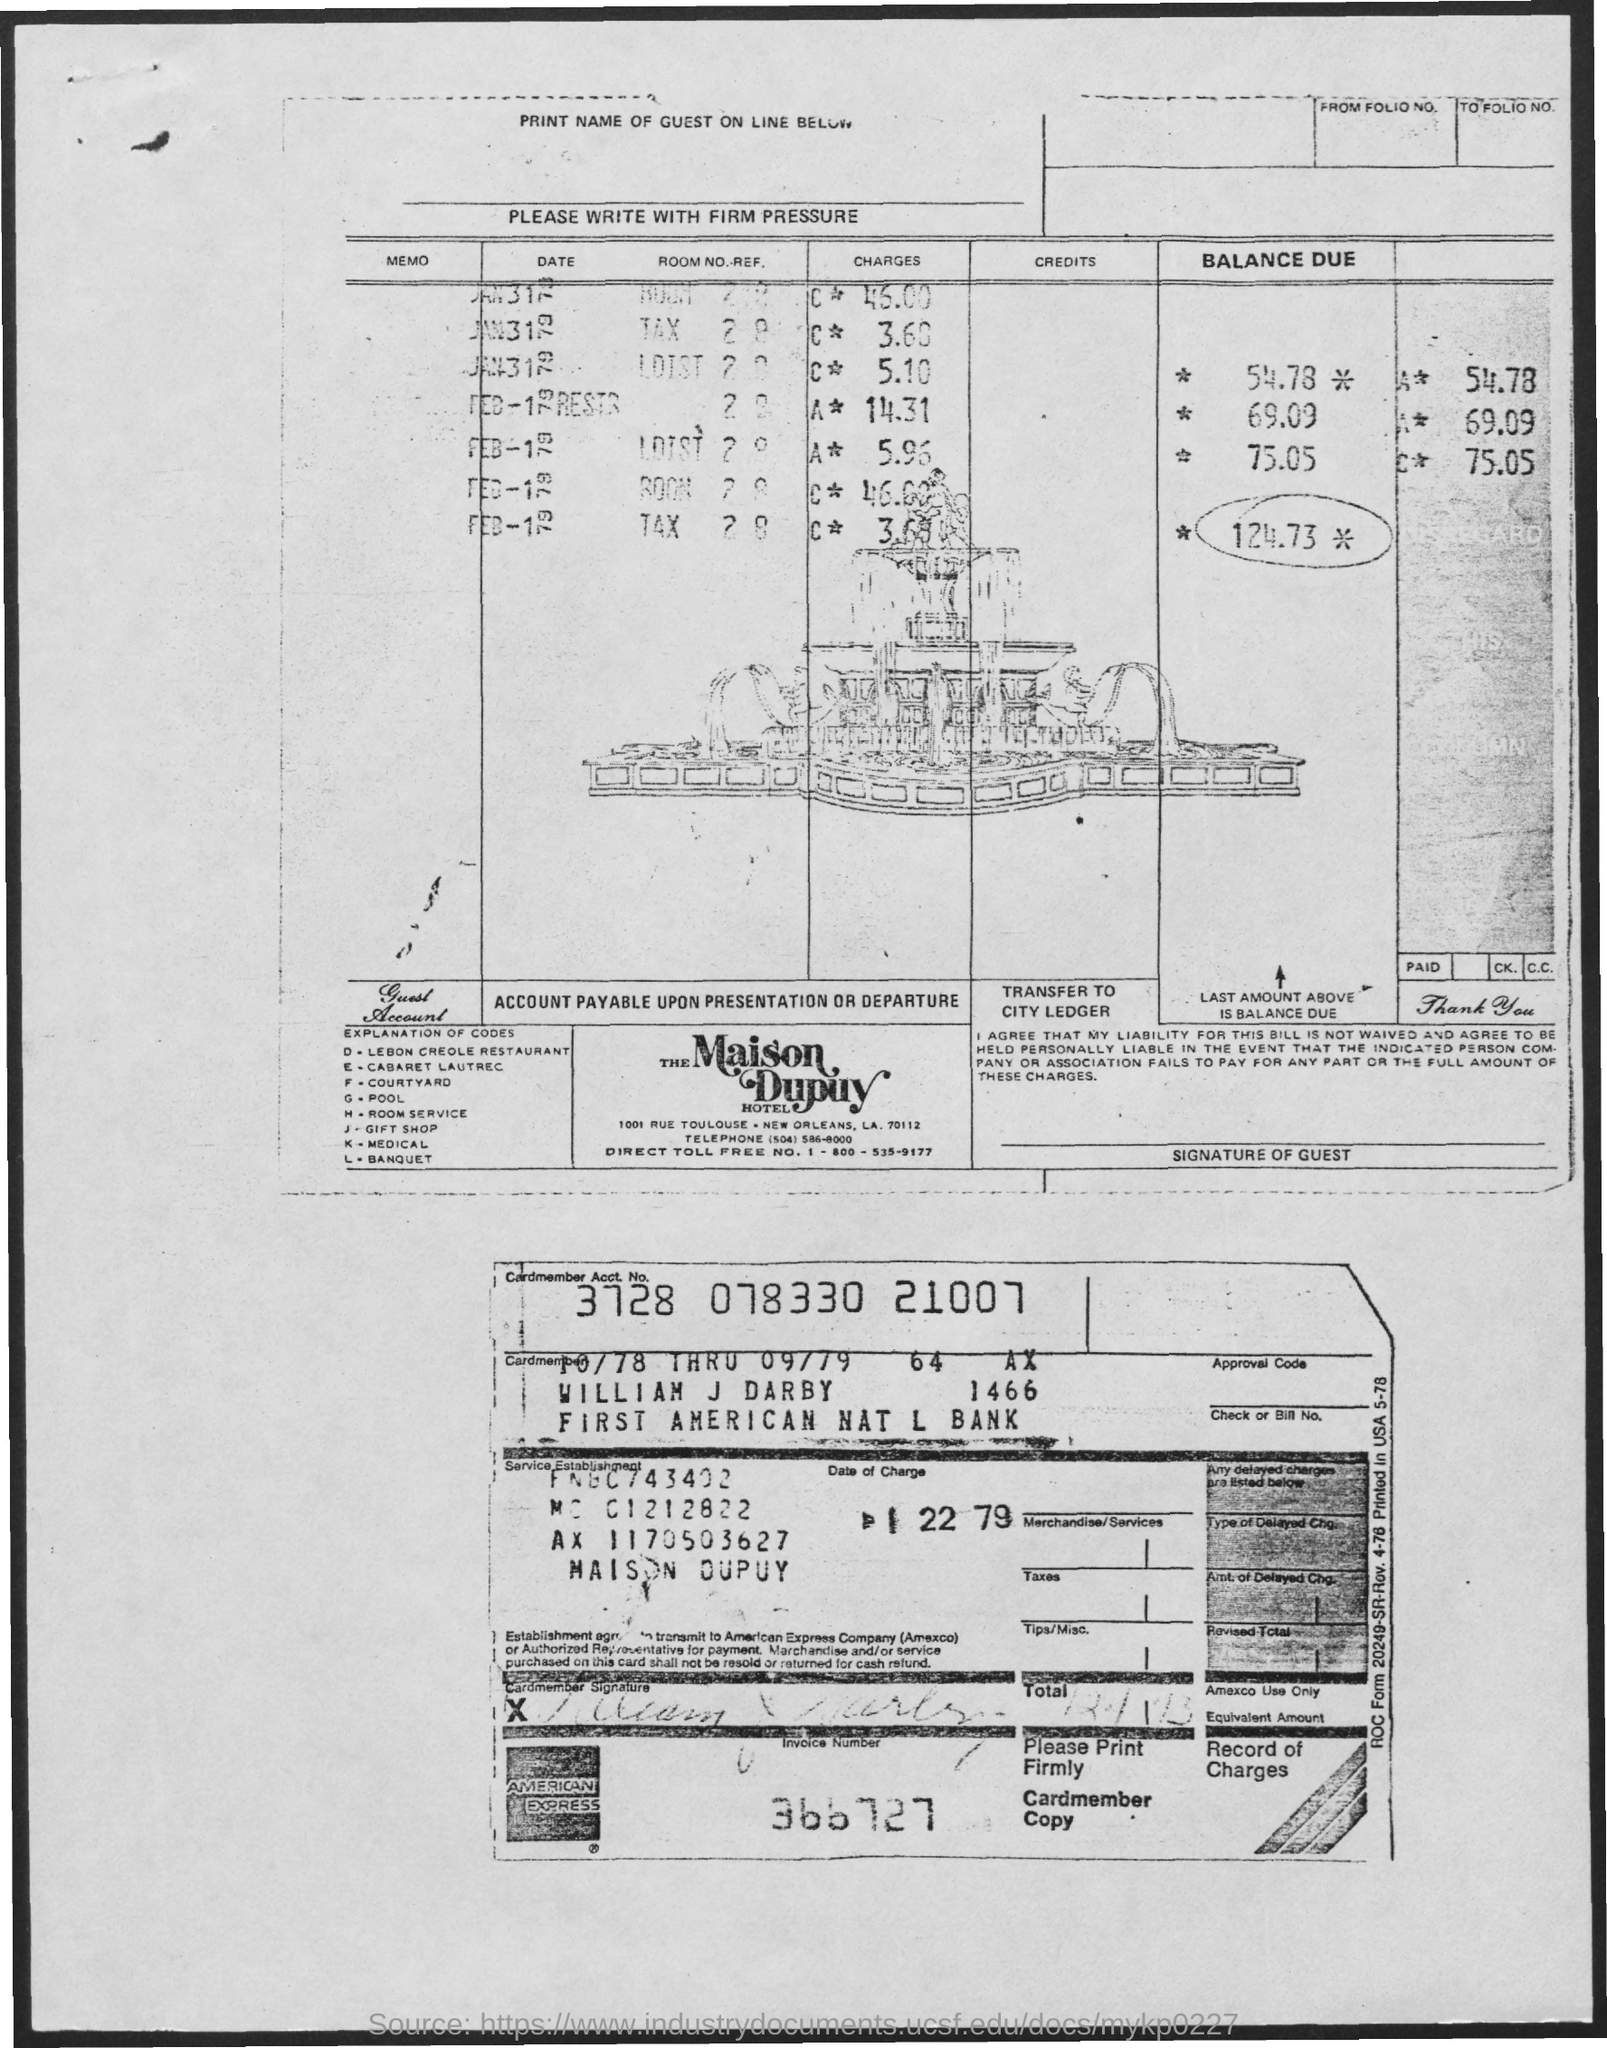Outline some significant characteristics in this image. The Cardmember Account Number is 3728 078330 21007. The invoice number is 366727... The code "H" refers to room service and its purpose is to facilitate the ordering and delivery of food and other amenities to guests in a hotel or other accommodation. The code 'G' refers to a pool, which is a designated area for swimming or water-based activities. The code "J" represents a gift shop, which is a retail establishment that sells goods as gifts. 